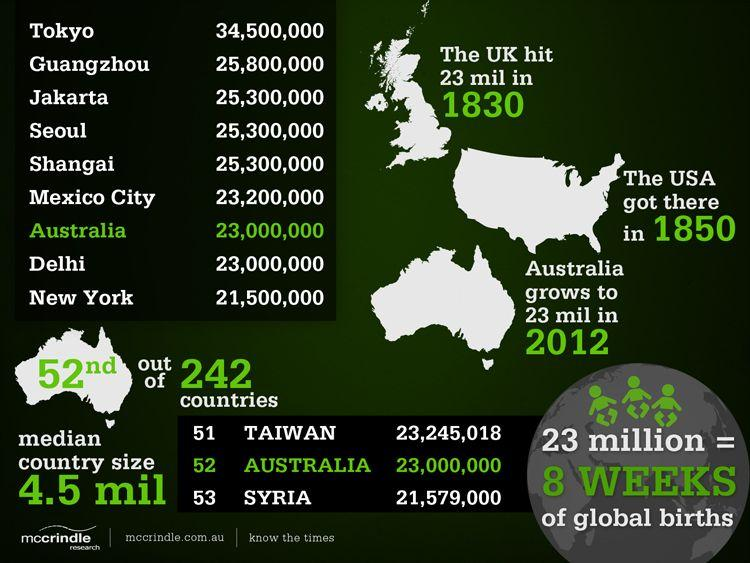Mention a couple of crucial points in this snapshot. By 1850, the United States of America had reached a population of 23 million people. In the year 1830, the United Kingdom reached a population of 23 million. Australia is a country that is highlighted in the color green. Australia is projected to reach a population of 23 million by 2012. According to the infographic, the equivalent of 23 million population can be represented by 8 weeks of global births. 